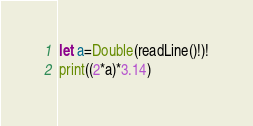<code> <loc_0><loc_0><loc_500><loc_500><_Swift_>let a=Double(readLine()!)!
print((2*a)*3.14)</code> 